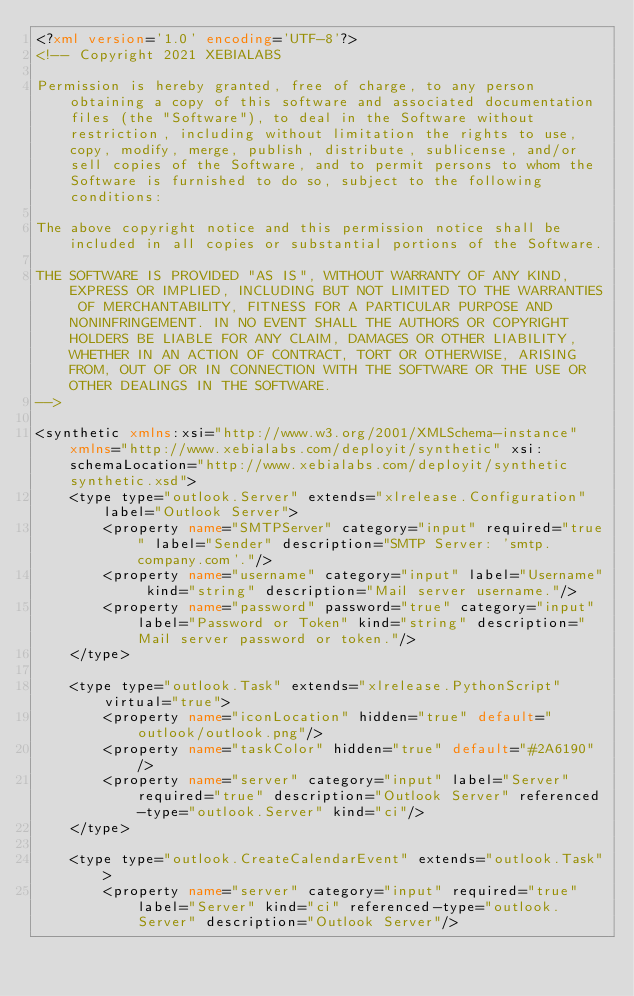<code> <loc_0><loc_0><loc_500><loc_500><_XML_><?xml version='1.0' encoding='UTF-8'?>
<!-- Copyright 2021 XEBIALABS

Permission is hereby granted, free of charge, to any person obtaining a copy of this software and associated documentation files (the "Software"), to deal in the Software without restriction, including without limitation the rights to use, copy, modify, merge, publish, distribute, sublicense, and/or sell copies of the Software, and to permit persons to whom the Software is furnished to do so, subject to the following conditions:

The above copyright notice and this permission notice shall be included in all copies or substantial portions of the Software.

THE SOFTWARE IS PROVIDED "AS IS", WITHOUT WARRANTY OF ANY KIND, EXPRESS OR IMPLIED, INCLUDING BUT NOT LIMITED TO THE WARRANTIES OF MERCHANTABILITY, FITNESS FOR A PARTICULAR PURPOSE AND NONINFRINGEMENT. IN NO EVENT SHALL THE AUTHORS OR COPYRIGHT HOLDERS BE LIABLE FOR ANY CLAIM, DAMAGES OR OTHER LIABILITY, WHETHER IN AN ACTION OF CONTRACT, TORT OR OTHERWISE, ARISING FROM, OUT OF OR IN CONNECTION WITH THE SOFTWARE OR THE USE OR OTHER DEALINGS IN THE SOFTWARE.
-->

<synthetic xmlns:xsi="http://www.w3.org/2001/XMLSchema-instance" xmlns="http://www.xebialabs.com/deployit/synthetic" xsi:schemaLocation="http://www.xebialabs.com/deployit/synthetic synthetic.xsd">
    <type type="outlook.Server" extends="xlrelease.Configuration" label="Outlook Server">
        <property name="SMTPServer" category="input" required="true" label="Sender" description="SMTP Server: 'smtp.company.com'."/>
        <property name="username" category="input" label="Username" kind="string" description="Mail server username."/>
        <property name="password" password="true" category="input" label="Password or Token" kind="string" description="Mail server password or token."/>
    </type>

    <type type="outlook.Task" extends="xlrelease.PythonScript" virtual="true">
        <property name="iconLocation" hidden="true" default="outlook/outlook.png"/>
        <property name="taskColor" hidden="true" default="#2A6190"/>
        <property name="server" category="input" label="Server" required="true" description="Outlook Server" referenced-type="outlook.Server" kind="ci"/>
    </type>

    <type type="outlook.CreateCalendarEvent" extends="outlook.Task">
        <property name="server" category="input" required="true" label="Server" kind="ci" referenced-type="outlook.Server" description="Outlook Server"/></code> 